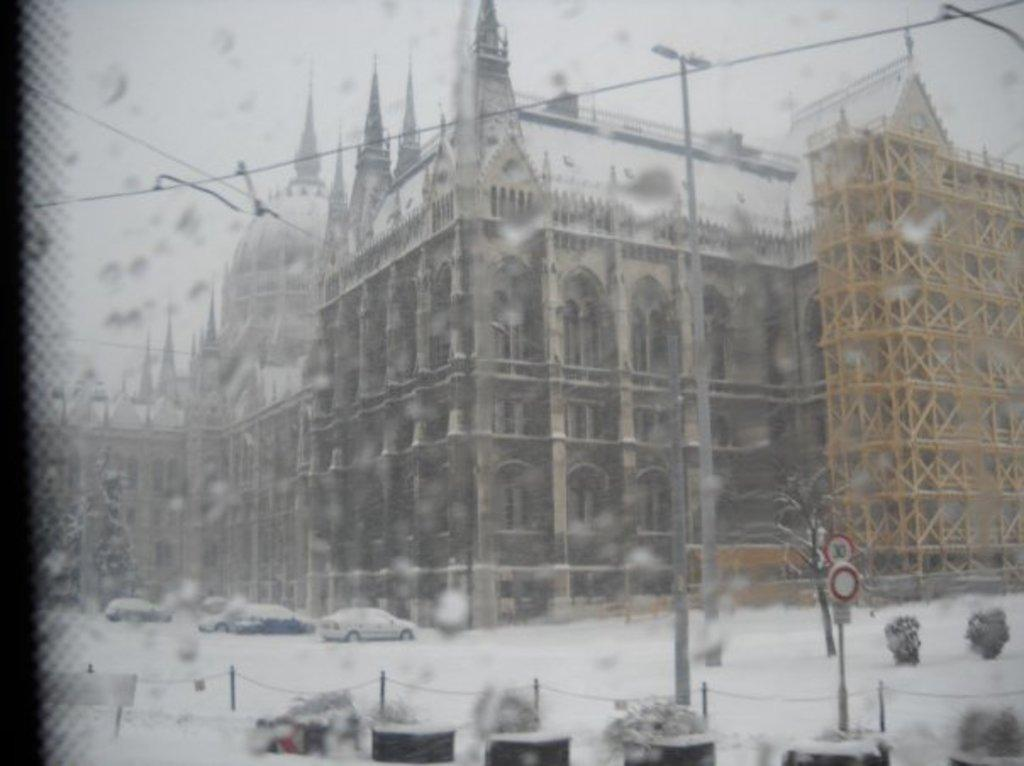What is the main subject of the image? The image appears to be a screen displaying a scene. What type of structures can be seen in the scene? There are buildings visible in the scene. What weather condition is depicted in the scene? Snow is present in the scene. What type of vegetation is visible in the scene? There are plants visible in the scene. What vehicles are affected by the snow in the scene? Cars covered with snow are present in the scene. What is visible at the top of the scene? The sky is visible at the top of the scene. What type of credit card is being used to purchase the snow in the image? There is no credit card or purchase of snow depicted in the image; it is a scene displaying snow and other elements. 